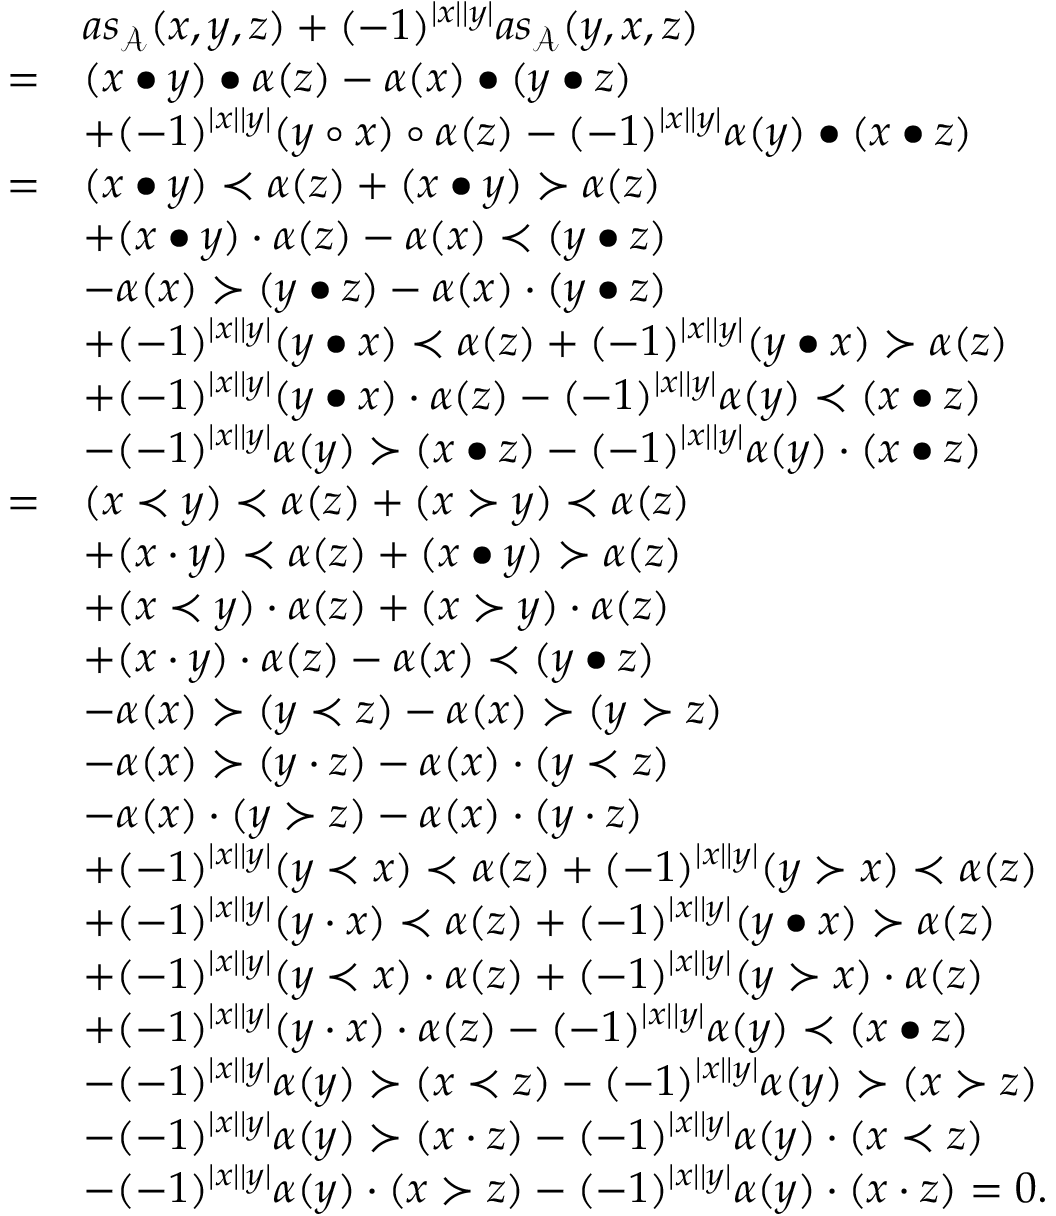<formula> <loc_0><loc_0><loc_500><loc_500>\begin{array} { r l } & { a s _ { \mathcal { A } } ( x , y , z ) + ( - 1 ) ^ { | x | | y | } a s _ { \mathcal { A } } ( y , x , z ) } \\ { = } & { ( x \bullet y ) \bullet \alpha ( z ) - \alpha ( x ) \bullet ( y \bullet z ) } \\ & { + ( - 1 ) ^ { | x | | y | } ( y \circ x ) \circ \alpha ( z ) - ( - 1 ) ^ { | x | | y | } \alpha ( y ) \bullet ( x \bullet z ) } \\ { = } & { ( x \bullet y ) \prec \alpha ( z ) + ( x \bullet y ) \succ \alpha ( z ) } \\ & { + ( x \bullet y ) \cdot \alpha ( z ) - \alpha ( x ) \prec ( y \bullet z ) } \\ & { - \alpha ( x ) \succ ( y \bullet z ) - \alpha ( x ) \cdot ( y \bullet z ) } \\ & { + ( - 1 ) ^ { | x | | y | } ( y \bullet x ) \prec \alpha ( z ) + ( - 1 ) ^ { | x | | y | } ( y \bullet x ) \succ \alpha ( z ) } \\ & { + ( - 1 ) ^ { | x | | y | } ( y \bullet x ) \cdot \alpha ( z ) - ( - 1 ) ^ { | x | | y | } \alpha ( y ) \prec ( x \bullet z ) } \\ & { - ( - 1 ) ^ { | x | | y | } \alpha ( y ) \succ ( x \bullet z ) - ( - 1 ) ^ { | x | | y | } \alpha ( y ) \cdot ( x \bullet z ) } \\ { = } & { ( x \prec y ) \prec \alpha ( z ) + ( x \succ y ) \prec \alpha ( z ) } \\ & { + ( x \cdot y ) \prec \alpha ( z ) + ( x \bullet y ) \succ \alpha ( z ) } \\ & { + ( x \prec y ) \cdot \alpha ( z ) + ( x \succ y ) \cdot \alpha ( z ) } \\ & { + ( x \cdot y ) \cdot \alpha ( z ) - \alpha ( x ) \prec ( y \bullet z ) } \\ & { - \alpha ( x ) \succ ( y \prec z ) - \alpha ( x ) \succ ( y \succ z ) } \\ & { - \alpha ( x ) \succ ( y \cdot z ) - \alpha ( x ) \cdot ( y \prec z ) } \\ & { - \alpha ( x ) \cdot ( y \succ z ) - \alpha ( x ) \cdot ( y \cdot z ) } \\ & { + ( - 1 ) ^ { | x | | y | } ( y \prec x ) \prec \alpha ( z ) + ( - 1 ) ^ { | x | | y | } ( y \succ x ) \prec \alpha ( z ) } \\ & { + ( - 1 ) ^ { | x | | y | } ( y \cdot x ) \prec \alpha ( z ) + ( - 1 ) ^ { | x | | y | } ( y \bullet x ) \succ \alpha ( z ) } \\ & { + ( - 1 ) ^ { | x | | y | } ( y \prec x ) \cdot \alpha ( z ) + ( - 1 ) ^ { | x | | y | } ( y \succ x ) \cdot \alpha ( z ) } \\ & { + ( - 1 ) ^ { | x | | y | } ( y \cdot x ) \cdot \alpha ( z ) - ( - 1 ) ^ { | x | | y | } \alpha ( y ) \prec ( x \bullet z ) } \\ & { - ( - 1 ) ^ { | x | | y | } \alpha ( y ) \succ ( x \prec z ) - ( - 1 ) ^ { | x | | y | } \alpha ( y ) \succ ( x \succ z ) } \\ & { - ( - 1 ) ^ { | x | | y | } \alpha ( y ) \succ ( x \cdot z ) - ( - 1 ) ^ { | x | | y | } \alpha ( y ) \cdot ( x \prec z ) } \\ & { - ( - 1 ) ^ { | x | | y | } \alpha ( y ) \cdot ( x \succ z ) - ( - 1 ) ^ { | x | | y | } \alpha ( y ) \cdot ( x \cdot z ) = 0 . } \end{array}</formula> 